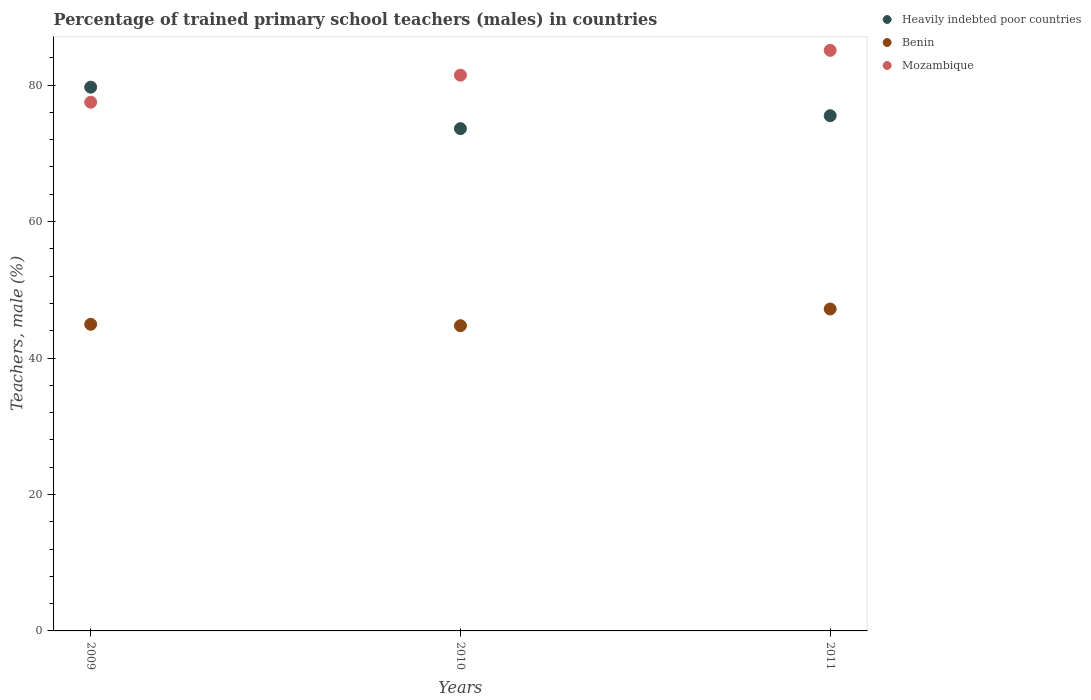Is the number of dotlines equal to the number of legend labels?
Offer a very short reply. Yes. What is the percentage of trained primary school teachers (males) in Benin in 2011?
Provide a succinct answer. 47.19. Across all years, what is the maximum percentage of trained primary school teachers (males) in Heavily indebted poor countries?
Your answer should be very brief. 79.7. Across all years, what is the minimum percentage of trained primary school teachers (males) in Heavily indebted poor countries?
Ensure brevity in your answer.  73.62. In which year was the percentage of trained primary school teachers (males) in Mozambique minimum?
Make the answer very short. 2009. What is the total percentage of trained primary school teachers (males) in Mozambique in the graph?
Make the answer very short. 244.05. What is the difference between the percentage of trained primary school teachers (males) in Heavily indebted poor countries in 2009 and that in 2010?
Keep it short and to the point. 6.08. What is the difference between the percentage of trained primary school teachers (males) in Heavily indebted poor countries in 2011 and the percentage of trained primary school teachers (males) in Benin in 2009?
Offer a very short reply. 30.58. What is the average percentage of trained primary school teachers (males) in Heavily indebted poor countries per year?
Your response must be concise. 76.28. In the year 2011, what is the difference between the percentage of trained primary school teachers (males) in Benin and percentage of trained primary school teachers (males) in Mozambique?
Provide a succinct answer. -37.91. In how many years, is the percentage of trained primary school teachers (males) in Heavily indebted poor countries greater than 24 %?
Give a very brief answer. 3. What is the ratio of the percentage of trained primary school teachers (males) in Mozambique in 2009 to that in 2011?
Keep it short and to the point. 0.91. Is the percentage of trained primary school teachers (males) in Heavily indebted poor countries in 2009 less than that in 2010?
Your answer should be compact. No. Is the difference between the percentage of trained primary school teachers (males) in Benin in 2009 and 2010 greater than the difference between the percentage of trained primary school teachers (males) in Mozambique in 2009 and 2010?
Your answer should be very brief. Yes. What is the difference between the highest and the second highest percentage of trained primary school teachers (males) in Mozambique?
Your response must be concise. 3.64. What is the difference between the highest and the lowest percentage of trained primary school teachers (males) in Benin?
Offer a terse response. 2.45. In how many years, is the percentage of trained primary school teachers (males) in Mozambique greater than the average percentage of trained primary school teachers (males) in Mozambique taken over all years?
Give a very brief answer. 2. Is the sum of the percentage of trained primary school teachers (males) in Mozambique in 2009 and 2011 greater than the maximum percentage of trained primary school teachers (males) in Heavily indebted poor countries across all years?
Provide a short and direct response. Yes. Are the values on the major ticks of Y-axis written in scientific E-notation?
Offer a very short reply. No. How are the legend labels stacked?
Your answer should be compact. Vertical. What is the title of the graph?
Give a very brief answer. Percentage of trained primary school teachers (males) in countries. Does "Armenia" appear as one of the legend labels in the graph?
Your answer should be very brief. No. What is the label or title of the X-axis?
Give a very brief answer. Years. What is the label or title of the Y-axis?
Keep it short and to the point. Teachers, male (%). What is the Teachers, male (%) in Heavily indebted poor countries in 2009?
Your answer should be compact. 79.7. What is the Teachers, male (%) in Benin in 2009?
Your answer should be very brief. 44.94. What is the Teachers, male (%) in Mozambique in 2009?
Give a very brief answer. 77.5. What is the Teachers, male (%) of Heavily indebted poor countries in 2010?
Keep it short and to the point. 73.62. What is the Teachers, male (%) in Benin in 2010?
Offer a very short reply. 44.74. What is the Teachers, male (%) of Mozambique in 2010?
Keep it short and to the point. 81.46. What is the Teachers, male (%) of Heavily indebted poor countries in 2011?
Your response must be concise. 75.52. What is the Teachers, male (%) of Benin in 2011?
Offer a very short reply. 47.19. What is the Teachers, male (%) of Mozambique in 2011?
Keep it short and to the point. 85.1. Across all years, what is the maximum Teachers, male (%) in Heavily indebted poor countries?
Provide a short and direct response. 79.7. Across all years, what is the maximum Teachers, male (%) in Benin?
Keep it short and to the point. 47.19. Across all years, what is the maximum Teachers, male (%) in Mozambique?
Your response must be concise. 85.1. Across all years, what is the minimum Teachers, male (%) of Heavily indebted poor countries?
Offer a very short reply. 73.62. Across all years, what is the minimum Teachers, male (%) of Benin?
Your response must be concise. 44.74. Across all years, what is the minimum Teachers, male (%) of Mozambique?
Your answer should be very brief. 77.5. What is the total Teachers, male (%) of Heavily indebted poor countries in the graph?
Offer a terse response. 228.84. What is the total Teachers, male (%) in Benin in the graph?
Ensure brevity in your answer.  136.86. What is the total Teachers, male (%) in Mozambique in the graph?
Provide a succinct answer. 244.05. What is the difference between the Teachers, male (%) of Heavily indebted poor countries in 2009 and that in 2010?
Make the answer very short. 6.08. What is the difference between the Teachers, male (%) of Benin in 2009 and that in 2010?
Your answer should be very brief. 0.21. What is the difference between the Teachers, male (%) in Mozambique in 2009 and that in 2010?
Your answer should be compact. -3.96. What is the difference between the Teachers, male (%) of Heavily indebted poor countries in 2009 and that in 2011?
Make the answer very short. 4.18. What is the difference between the Teachers, male (%) of Benin in 2009 and that in 2011?
Offer a terse response. -2.24. What is the difference between the Teachers, male (%) in Mozambique in 2009 and that in 2011?
Provide a succinct answer. -7.6. What is the difference between the Teachers, male (%) in Heavily indebted poor countries in 2010 and that in 2011?
Keep it short and to the point. -1.9. What is the difference between the Teachers, male (%) in Benin in 2010 and that in 2011?
Offer a very short reply. -2.45. What is the difference between the Teachers, male (%) in Mozambique in 2010 and that in 2011?
Your response must be concise. -3.64. What is the difference between the Teachers, male (%) of Heavily indebted poor countries in 2009 and the Teachers, male (%) of Benin in 2010?
Offer a terse response. 34.96. What is the difference between the Teachers, male (%) in Heavily indebted poor countries in 2009 and the Teachers, male (%) in Mozambique in 2010?
Offer a terse response. -1.76. What is the difference between the Teachers, male (%) of Benin in 2009 and the Teachers, male (%) of Mozambique in 2010?
Give a very brief answer. -36.52. What is the difference between the Teachers, male (%) of Heavily indebted poor countries in 2009 and the Teachers, male (%) of Benin in 2011?
Provide a short and direct response. 32.51. What is the difference between the Teachers, male (%) of Heavily indebted poor countries in 2009 and the Teachers, male (%) of Mozambique in 2011?
Keep it short and to the point. -5.4. What is the difference between the Teachers, male (%) in Benin in 2009 and the Teachers, male (%) in Mozambique in 2011?
Make the answer very short. -40.16. What is the difference between the Teachers, male (%) in Heavily indebted poor countries in 2010 and the Teachers, male (%) in Benin in 2011?
Keep it short and to the point. 26.44. What is the difference between the Teachers, male (%) of Heavily indebted poor countries in 2010 and the Teachers, male (%) of Mozambique in 2011?
Provide a succinct answer. -11.47. What is the difference between the Teachers, male (%) of Benin in 2010 and the Teachers, male (%) of Mozambique in 2011?
Keep it short and to the point. -40.36. What is the average Teachers, male (%) of Heavily indebted poor countries per year?
Your response must be concise. 76.28. What is the average Teachers, male (%) in Benin per year?
Your answer should be compact. 45.62. What is the average Teachers, male (%) of Mozambique per year?
Offer a very short reply. 81.35. In the year 2009, what is the difference between the Teachers, male (%) of Heavily indebted poor countries and Teachers, male (%) of Benin?
Offer a terse response. 34.76. In the year 2009, what is the difference between the Teachers, male (%) in Heavily indebted poor countries and Teachers, male (%) in Mozambique?
Ensure brevity in your answer.  2.2. In the year 2009, what is the difference between the Teachers, male (%) of Benin and Teachers, male (%) of Mozambique?
Provide a short and direct response. -32.56. In the year 2010, what is the difference between the Teachers, male (%) in Heavily indebted poor countries and Teachers, male (%) in Benin?
Your answer should be compact. 28.89. In the year 2010, what is the difference between the Teachers, male (%) in Heavily indebted poor countries and Teachers, male (%) in Mozambique?
Keep it short and to the point. -7.83. In the year 2010, what is the difference between the Teachers, male (%) of Benin and Teachers, male (%) of Mozambique?
Offer a terse response. -36.72. In the year 2011, what is the difference between the Teachers, male (%) of Heavily indebted poor countries and Teachers, male (%) of Benin?
Give a very brief answer. 28.33. In the year 2011, what is the difference between the Teachers, male (%) of Heavily indebted poor countries and Teachers, male (%) of Mozambique?
Ensure brevity in your answer.  -9.58. In the year 2011, what is the difference between the Teachers, male (%) of Benin and Teachers, male (%) of Mozambique?
Offer a terse response. -37.91. What is the ratio of the Teachers, male (%) in Heavily indebted poor countries in 2009 to that in 2010?
Offer a very short reply. 1.08. What is the ratio of the Teachers, male (%) of Mozambique in 2009 to that in 2010?
Provide a succinct answer. 0.95. What is the ratio of the Teachers, male (%) of Heavily indebted poor countries in 2009 to that in 2011?
Your answer should be very brief. 1.06. What is the ratio of the Teachers, male (%) of Benin in 2009 to that in 2011?
Make the answer very short. 0.95. What is the ratio of the Teachers, male (%) of Mozambique in 2009 to that in 2011?
Your answer should be compact. 0.91. What is the ratio of the Teachers, male (%) of Heavily indebted poor countries in 2010 to that in 2011?
Your answer should be compact. 0.97. What is the ratio of the Teachers, male (%) of Benin in 2010 to that in 2011?
Your response must be concise. 0.95. What is the ratio of the Teachers, male (%) in Mozambique in 2010 to that in 2011?
Provide a succinct answer. 0.96. What is the difference between the highest and the second highest Teachers, male (%) of Heavily indebted poor countries?
Your response must be concise. 4.18. What is the difference between the highest and the second highest Teachers, male (%) in Benin?
Offer a terse response. 2.24. What is the difference between the highest and the second highest Teachers, male (%) in Mozambique?
Your response must be concise. 3.64. What is the difference between the highest and the lowest Teachers, male (%) in Heavily indebted poor countries?
Provide a short and direct response. 6.08. What is the difference between the highest and the lowest Teachers, male (%) of Benin?
Your answer should be very brief. 2.45. What is the difference between the highest and the lowest Teachers, male (%) of Mozambique?
Provide a succinct answer. 7.6. 